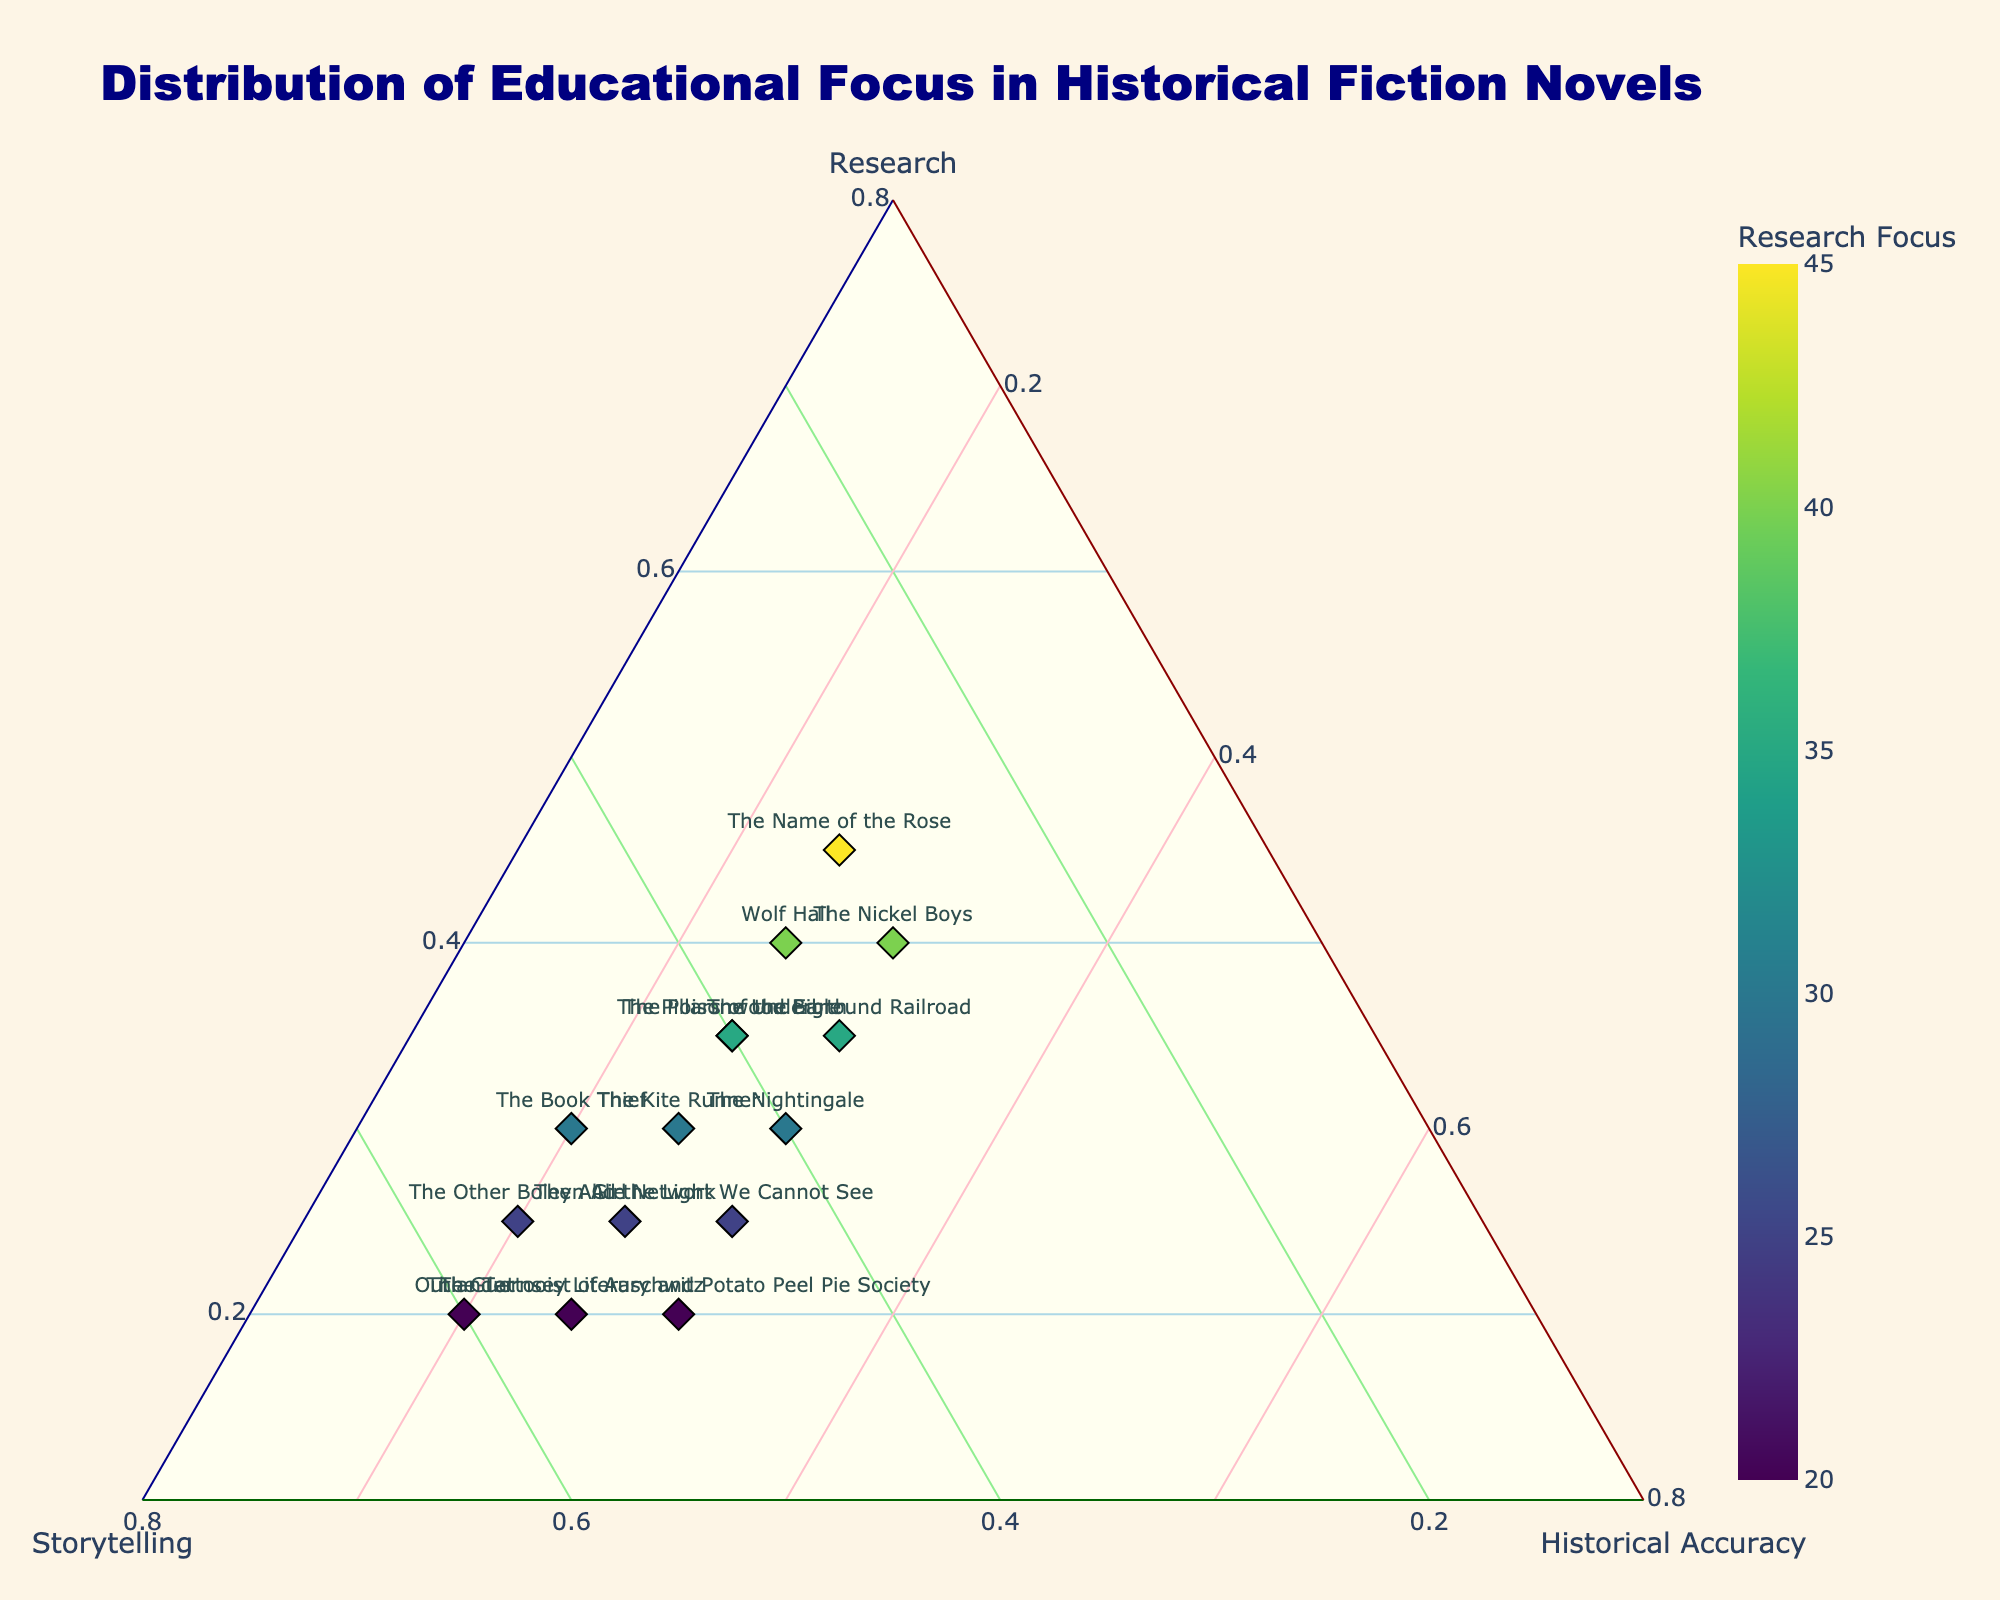What's the title of the plot? The title is prominently displayed at the top of the plot. It describes the main focus of the visualization.
Answer: Distribution of Educational Focus in Historical Fiction Novels Which axis represents "Storytelling"? The axes of a ternary plot are usually labeled at their endpoints. You can find "Storytelling" at one edge of the triangle.
Answer: The left axis Which novel has the highest focus on research? By looking at the color intensity on the plot's markers and the coloring legend, we can determine which novel has the deepest color correlated with the highest research focus.
Answer: The Name of the Rose What is the ratio of storytelling to research focus in "Outlander"? By referring to the position of "Outlander" on the ternary plot, and noting the coordinates, we see its normalized values for storytelling and research, which directly gives their ratio.
Answer: 3:1 How many novels have an equal focus on storytelling and historical accuracy? We look for novels situated on the line where the normalized values for storytelling and historical accuracy are equal. This equality is observed based on the coordinates. Three books are closest based on their positions.
Answer: 3 novels Between "The Book Thief" and "The Kite Runner," which one has a higher focus on historical accuracy? Comparing their respective points on the ternary plot, we note which one has a higher value on the historical accuracy axis.
Answer: "All the Light We Cannot See" If you sum up the focus on research and storytelling for "The Other Boleyn Girl," what do you get? Adding the percent focuses for research and storytelling based on positions: 25% + 55%.
Answer: 80% Which novel balances all three aspects (research, storytelling, historical accuracy) most evenly? Look for the point closest to the center of the ternary plot, indicating an equal distribution of all three components.
Answer: The Underground Railroad Compare the historical accuracy focus between "The Nightingale" and "The Nickel Boys." Which one has less focus on historical accuracy? Observing their respective positions on the historical accuracy axis, determine which has a lower value.
Answer: The Nightingale Is there a novel that has a higher emphasis on storytelling but equal split on research and historical accuracy? Check for a point where storytelling is clearest and the other two coordinates are equidistant, indicating an equal split of research and historical accuracy proportions.
Answer: The Alice Network 